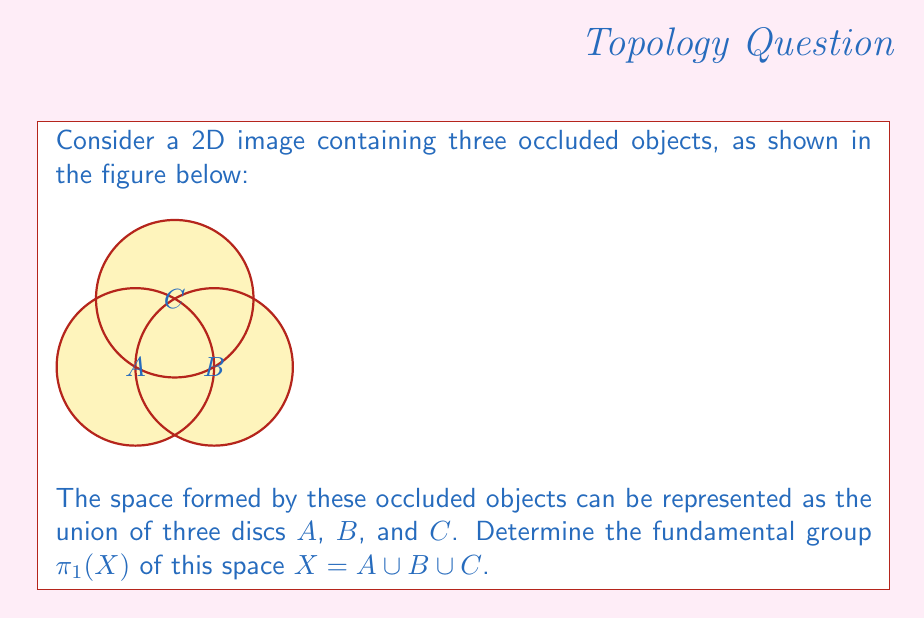What is the answer to this math problem? To determine the fundamental group of the space $X$, we'll follow these steps:

1) First, observe that the space $X$ is path-connected, as any two points can be connected by a path within the union of the three discs.

2) The key insight is that this space is homotopy equivalent to a wedge sum of two circles. We can see this by:
   a) Contracting disc $A$ to a point
   b) Sliding the intersection of $B$ and $C$ along until it touches the contracted $A$

3) After these deformations, we're left with a space that looks like a figure-eight, which is the wedge sum of two circles: $S^1 \vee S^1$.

4) The fundamental group of a wedge sum of circles is isomorphic to the free group on as many generators as there are circles. In this case, we have two circles, so:

   $$\pi_1(X) \cong \pi_1(S^1 \vee S^1) \cong F_2$$

   where $F_2$ is the free group on two generators.

5) We can represent this group abstractly as:

   $$\pi_1(X) \cong \langle a, b \rangle$$

   where $a$ and $b$ are the generators corresponding to loops around each of the holes in our figure-eight.

This result tells us that the fundamental group of our space of occluded objects has two degrees of freedom, corresponding to the two ways a loop can wind around the holes in the space.
Answer: $\pi_1(X) \cong F_2$ 